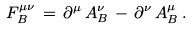Convert formula to latex. <formula><loc_0><loc_0><loc_500><loc_500>F _ { B } ^ { \mu \nu } \, = \, \partial ^ { \mu } \, A _ { B } ^ { \nu } \, - \, \partial ^ { \nu } \, A _ { B } ^ { \mu } \, .</formula> 